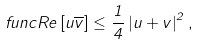Convert formula to latex. <formula><loc_0><loc_0><loc_500><loc_500>\ f u n c { R e } \left [ u \overline { v } \right ] \leq \frac { 1 } { 4 } \left | u + v \right | ^ { 2 } ,</formula> 